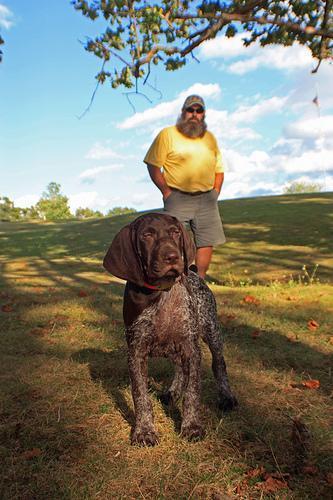How many dogs are there?
Give a very brief answer. 1. 